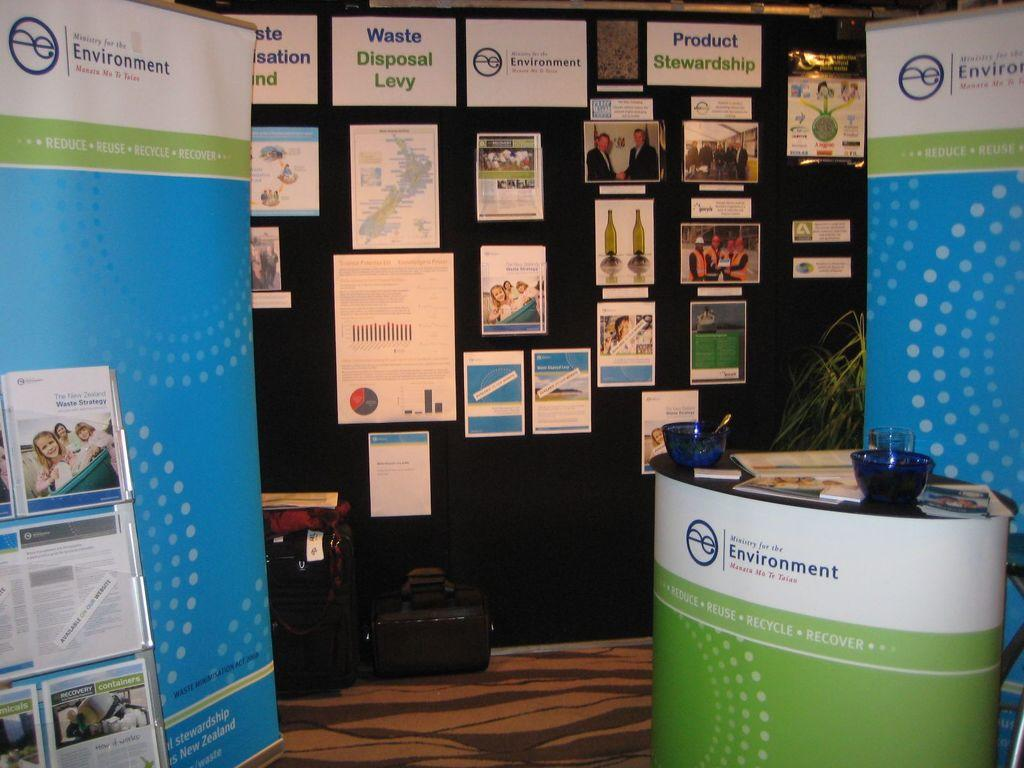<image>
Create a compact narrative representing the image presented. The Ministry of the Environment hosts a booth providing information on the waste disposal levy/ 